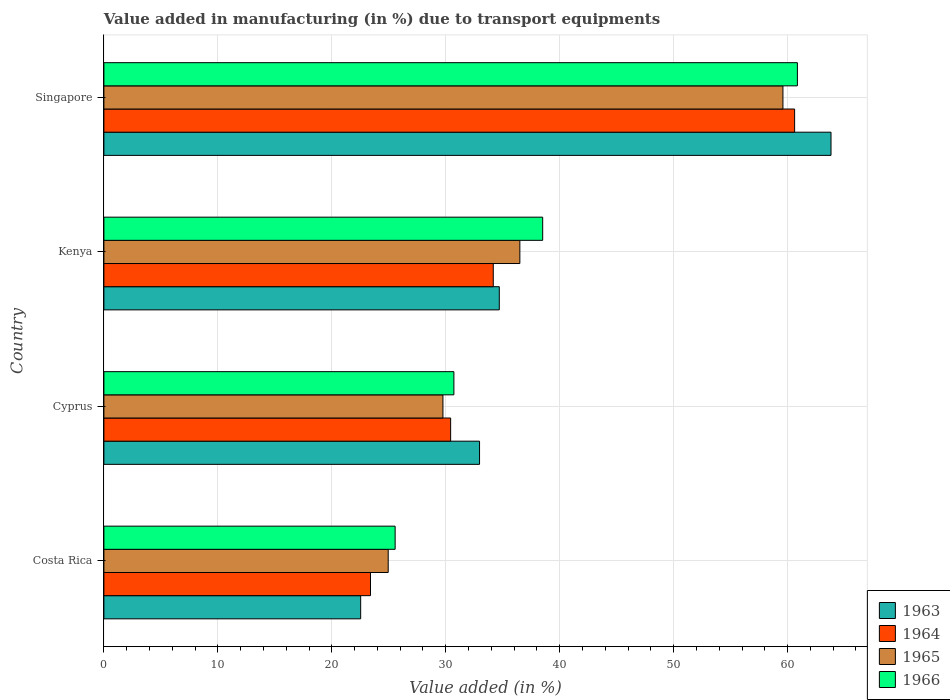How many groups of bars are there?
Make the answer very short. 4. Are the number of bars per tick equal to the number of legend labels?
Offer a very short reply. Yes. Are the number of bars on each tick of the Y-axis equal?
Offer a very short reply. Yes. How many bars are there on the 4th tick from the top?
Your answer should be compact. 4. How many bars are there on the 1st tick from the bottom?
Offer a terse response. 4. What is the label of the 2nd group of bars from the top?
Your answer should be very brief. Kenya. What is the percentage of value added in manufacturing due to transport equipments in 1966 in Singapore?
Make the answer very short. 60.86. Across all countries, what is the maximum percentage of value added in manufacturing due to transport equipments in 1966?
Offer a very short reply. 60.86. Across all countries, what is the minimum percentage of value added in manufacturing due to transport equipments in 1965?
Ensure brevity in your answer.  24.95. In which country was the percentage of value added in manufacturing due to transport equipments in 1963 maximum?
Keep it short and to the point. Singapore. What is the total percentage of value added in manufacturing due to transport equipments in 1966 in the graph?
Provide a succinct answer. 155.64. What is the difference between the percentage of value added in manufacturing due to transport equipments in 1964 in Costa Rica and that in Singapore?
Provide a short and direct response. -37.22. What is the difference between the percentage of value added in manufacturing due to transport equipments in 1964 in Costa Rica and the percentage of value added in manufacturing due to transport equipments in 1966 in Singapore?
Ensure brevity in your answer.  -37.46. What is the average percentage of value added in manufacturing due to transport equipments in 1963 per country?
Give a very brief answer. 38.5. What is the difference between the percentage of value added in manufacturing due to transport equipments in 1965 and percentage of value added in manufacturing due to transport equipments in 1964 in Costa Rica?
Make the answer very short. 1.55. What is the ratio of the percentage of value added in manufacturing due to transport equipments in 1964 in Kenya to that in Singapore?
Provide a short and direct response. 0.56. Is the difference between the percentage of value added in manufacturing due to transport equipments in 1965 in Cyprus and Kenya greater than the difference between the percentage of value added in manufacturing due to transport equipments in 1964 in Cyprus and Kenya?
Provide a short and direct response. No. What is the difference between the highest and the second highest percentage of value added in manufacturing due to transport equipments in 1963?
Your response must be concise. 29.11. What is the difference between the highest and the lowest percentage of value added in manufacturing due to transport equipments in 1966?
Your response must be concise. 35.3. What does the 1st bar from the top in Cyprus represents?
Keep it short and to the point. 1966. What does the 2nd bar from the bottom in Costa Rica represents?
Your answer should be very brief. 1964. Is it the case that in every country, the sum of the percentage of value added in manufacturing due to transport equipments in 1964 and percentage of value added in manufacturing due to transport equipments in 1965 is greater than the percentage of value added in manufacturing due to transport equipments in 1966?
Your response must be concise. Yes. How many bars are there?
Your answer should be very brief. 16. Are all the bars in the graph horizontal?
Offer a terse response. Yes. How many countries are there in the graph?
Your answer should be very brief. 4. Are the values on the major ticks of X-axis written in scientific E-notation?
Your answer should be compact. No. How many legend labels are there?
Offer a terse response. 4. How are the legend labels stacked?
Your response must be concise. Vertical. What is the title of the graph?
Give a very brief answer. Value added in manufacturing (in %) due to transport equipments. Does "1985" appear as one of the legend labels in the graph?
Ensure brevity in your answer.  No. What is the label or title of the X-axis?
Provide a succinct answer. Value added (in %). What is the label or title of the Y-axis?
Provide a succinct answer. Country. What is the Value added (in %) in 1963 in Costa Rica?
Your response must be concise. 22.53. What is the Value added (in %) of 1964 in Costa Rica?
Provide a short and direct response. 23.4. What is the Value added (in %) of 1965 in Costa Rica?
Make the answer very short. 24.95. What is the Value added (in %) in 1966 in Costa Rica?
Your response must be concise. 25.56. What is the Value added (in %) in 1963 in Cyprus?
Offer a very short reply. 32.97. What is the Value added (in %) of 1964 in Cyprus?
Make the answer very short. 30.43. What is the Value added (in %) in 1965 in Cyprus?
Your answer should be very brief. 29.75. What is the Value added (in %) in 1966 in Cyprus?
Your answer should be very brief. 30.72. What is the Value added (in %) in 1963 in Kenya?
Offer a terse response. 34.7. What is the Value added (in %) in 1964 in Kenya?
Your answer should be very brief. 34.17. What is the Value added (in %) in 1965 in Kenya?
Provide a short and direct response. 36.5. What is the Value added (in %) in 1966 in Kenya?
Ensure brevity in your answer.  38.51. What is the Value added (in %) of 1963 in Singapore?
Give a very brief answer. 63.81. What is the Value added (in %) in 1964 in Singapore?
Provide a succinct answer. 60.62. What is the Value added (in %) in 1965 in Singapore?
Your answer should be compact. 59.59. What is the Value added (in %) in 1966 in Singapore?
Provide a succinct answer. 60.86. Across all countries, what is the maximum Value added (in %) of 1963?
Make the answer very short. 63.81. Across all countries, what is the maximum Value added (in %) in 1964?
Offer a very short reply. 60.62. Across all countries, what is the maximum Value added (in %) of 1965?
Your answer should be very brief. 59.59. Across all countries, what is the maximum Value added (in %) of 1966?
Ensure brevity in your answer.  60.86. Across all countries, what is the minimum Value added (in %) of 1963?
Your answer should be very brief. 22.53. Across all countries, what is the minimum Value added (in %) in 1964?
Offer a terse response. 23.4. Across all countries, what is the minimum Value added (in %) in 1965?
Give a very brief answer. 24.95. Across all countries, what is the minimum Value added (in %) of 1966?
Offer a terse response. 25.56. What is the total Value added (in %) of 1963 in the graph?
Provide a short and direct response. 154.01. What is the total Value added (in %) in 1964 in the graph?
Offer a very short reply. 148.61. What is the total Value added (in %) in 1965 in the graph?
Offer a very short reply. 150.8. What is the total Value added (in %) of 1966 in the graph?
Give a very brief answer. 155.64. What is the difference between the Value added (in %) of 1963 in Costa Rica and that in Cyprus?
Your answer should be very brief. -10.43. What is the difference between the Value added (in %) of 1964 in Costa Rica and that in Cyprus?
Your answer should be very brief. -7.03. What is the difference between the Value added (in %) of 1965 in Costa Rica and that in Cyprus?
Ensure brevity in your answer.  -4.8. What is the difference between the Value added (in %) in 1966 in Costa Rica and that in Cyprus?
Your answer should be very brief. -5.16. What is the difference between the Value added (in %) of 1963 in Costa Rica and that in Kenya?
Your response must be concise. -12.17. What is the difference between the Value added (in %) of 1964 in Costa Rica and that in Kenya?
Offer a very short reply. -10.77. What is the difference between the Value added (in %) of 1965 in Costa Rica and that in Kenya?
Make the answer very short. -11.55. What is the difference between the Value added (in %) in 1966 in Costa Rica and that in Kenya?
Offer a terse response. -12.95. What is the difference between the Value added (in %) of 1963 in Costa Rica and that in Singapore?
Ensure brevity in your answer.  -41.28. What is the difference between the Value added (in %) of 1964 in Costa Rica and that in Singapore?
Give a very brief answer. -37.22. What is the difference between the Value added (in %) in 1965 in Costa Rica and that in Singapore?
Provide a succinct answer. -34.64. What is the difference between the Value added (in %) of 1966 in Costa Rica and that in Singapore?
Offer a terse response. -35.3. What is the difference between the Value added (in %) of 1963 in Cyprus and that in Kenya?
Give a very brief answer. -1.73. What is the difference between the Value added (in %) of 1964 in Cyprus and that in Kenya?
Offer a very short reply. -3.74. What is the difference between the Value added (in %) of 1965 in Cyprus and that in Kenya?
Provide a short and direct response. -6.75. What is the difference between the Value added (in %) in 1966 in Cyprus and that in Kenya?
Your answer should be very brief. -7.79. What is the difference between the Value added (in %) in 1963 in Cyprus and that in Singapore?
Offer a very short reply. -30.84. What is the difference between the Value added (in %) of 1964 in Cyprus and that in Singapore?
Your answer should be compact. -30.19. What is the difference between the Value added (in %) of 1965 in Cyprus and that in Singapore?
Your answer should be compact. -29.84. What is the difference between the Value added (in %) of 1966 in Cyprus and that in Singapore?
Offer a very short reply. -30.14. What is the difference between the Value added (in %) of 1963 in Kenya and that in Singapore?
Your response must be concise. -29.11. What is the difference between the Value added (in %) in 1964 in Kenya and that in Singapore?
Your answer should be very brief. -26.45. What is the difference between the Value added (in %) of 1965 in Kenya and that in Singapore?
Offer a very short reply. -23.09. What is the difference between the Value added (in %) of 1966 in Kenya and that in Singapore?
Provide a succinct answer. -22.35. What is the difference between the Value added (in %) in 1963 in Costa Rica and the Value added (in %) in 1964 in Cyprus?
Your answer should be very brief. -7.9. What is the difference between the Value added (in %) in 1963 in Costa Rica and the Value added (in %) in 1965 in Cyprus?
Offer a very short reply. -7.22. What is the difference between the Value added (in %) in 1963 in Costa Rica and the Value added (in %) in 1966 in Cyprus?
Your response must be concise. -8.18. What is the difference between the Value added (in %) of 1964 in Costa Rica and the Value added (in %) of 1965 in Cyprus?
Offer a very short reply. -6.36. What is the difference between the Value added (in %) in 1964 in Costa Rica and the Value added (in %) in 1966 in Cyprus?
Your answer should be very brief. -7.32. What is the difference between the Value added (in %) in 1965 in Costa Rica and the Value added (in %) in 1966 in Cyprus?
Keep it short and to the point. -5.77. What is the difference between the Value added (in %) in 1963 in Costa Rica and the Value added (in %) in 1964 in Kenya?
Offer a very short reply. -11.64. What is the difference between the Value added (in %) of 1963 in Costa Rica and the Value added (in %) of 1965 in Kenya?
Keep it short and to the point. -13.97. What is the difference between the Value added (in %) of 1963 in Costa Rica and the Value added (in %) of 1966 in Kenya?
Your response must be concise. -15.97. What is the difference between the Value added (in %) of 1964 in Costa Rica and the Value added (in %) of 1965 in Kenya?
Offer a very short reply. -13.11. What is the difference between the Value added (in %) in 1964 in Costa Rica and the Value added (in %) in 1966 in Kenya?
Make the answer very short. -15.11. What is the difference between the Value added (in %) of 1965 in Costa Rica and the Value added (in %) of 1966 in Kenya?
Give a very brief answer. -13.56. What is the difference between the Value added (in %) of 1963 in Costa Rica and the Value added (in %) of 1964 in Singapore?
Your answer should be compact. -38.08. What is the difference between the Value added (in %) of 1963 in Costa Rica and the Value added (in %) of 1965 in Singapore?
Give a very brief answer. -37.06. What is the difference between the Value added (in %) in 1963 in Costa Rica and the Value added (in %) in 1966 in Singapore?
Give a very brief answer. -38.33. What is the difference between the Value added (in %) in 1964 in Costa Rica and the Value added (in %) in 1965 in Singapore?
Provide a succinct answer. -36.19. What is the difference between the Value added (in %) in 1964 in Costa Rica and the Value added (in %) in 1966 in Singapore?
Your answer should be compact. -37.46. What is the difference between the Value added (in %) of 1965 in Costa Rica and the Value added (in %) of 1966 in Singapore?
Provide a short and direct response. -35.91. What is the difference between the Value added (in %) of 1963 in Cyprus and the Value added (in %) of 1964 in Kenya?
Make the answer very short. -1.2. What is the difference between the Value added (in %) of 1963 in Cyprus and the Value added (in %) of 1965 in Kenya?
Provide a short and direct response. -3.54. What is the difference between the Value added (in %) of 1963 in Cyprus and the Value added (in %) of 1966 in Kenya?
Provide a short and direct response. -5.54. What is the difference between the Value added (in %) in 1964 in Cyprus and the Value added (in %) in 1965 in Kenya?
Your answer should be very brief. -6.07. What is the difference between the Value added (in %) in 1964 in Cyprus and the Value added (in %) in 1966 in Kenya?
Your answer should be compact. -8.08. What is the difference between the Value added (in %) of 1965 in Cyprus and the Value added (in %) of 1966 in Kenya?
Your response must be concise. -8.75. What is the difference between the Value added (in %) of 1963 in Cyprus and the Value added (in %) of 1964 in Singapore?
Offer a very short reply. -27.65. What is the difference between the Value added (in %) in 1963 in Cyprus and the Value added (in %) in 1965 in Singapore?
Your answer should be compact. -26.62. What is the difference between the Value added (in %) in 1963 in Cyprus and the Value added (in %) in 1966 in Singapore?
Provide a succinct answer. -27.89. What is the difference between the Value added (in %) in 1964 in Cyprus and the Value added (in %) in 1965 in Singapore?
Offer a terse response. -29.16. What is the difference between the Value added (in %) in 1964 in Cyprus and the Value added (in %) in 1966 in Singapore?
Keep it short and to the point. -30.43. What is the difference between the Value added (in %) of 1965 in Cyprus and the Value added (in %) of 1966 in Singapore?
Your answer should be very brief. -31.11. What is the difference between the Value added (in %) in 1963 in Kenya and the Value added (in %) in 1964 in Singapore?
Provide a short and direct response. -25.92. What is the difference between the Value added (in %) of 1963 in Kenya and the Value added (in %) of 1965 in Singapore?
Offer a terse response. -24.89. What is the difference between the Value added (in %) of 1963 in Kenya and the Value added (in %) of 1966 in Singapore?
Provide a short and direct response. -26.16. What is the difference between the Value added (in %) in 1964 in Kenya and the Value added (in %) in 1965 in Singapore?
Ensure brevity in your answer.  -25.42. What is the difference between the Value added (in %) of 1964 in Kenya and the Value added (in %) of 1966 in Singapore?
Ensure brevity in your answer.  -26.69. What is the difference between the Value added (in %) of 1965 in Kenya and the Value added (in %) of 1966 in Singapore?
Provide a short and direct response. -24.36. What is the average Value added (in %) of 1963 per country?
Provide a succinct answer. 38.5. What is the average Value added (in %) of 1964 per country?
Your answer should be compact. 37.15. What is the average Value added (in %) of 1965 per country?
Provide a short and direct response. 37.7. What is the average Value added (in %) of 1966 per country?
Your answer should be very brief. 38.91. What is the difference between the Value added (in %) in 1963 and Value added (in %) in 1964 in Costa Rica?
Ensure brevity in your answer.  -0.86. What is the difference between the Value added (in %) in 1963 and Value added (in %) in 1965 in Costa Rica?
Provide a succinct answer. -2.42. What is the difference between the Value added (in %) of 1963 and Value added (in %) of 1966 in Costa Rica?
Ensure brevity in your answer.  -3.03. What is the difference between the Value added (in %) in 1964 and Value added (in %) in 1965 in Costa Rica?
Offer a very short reply. -1.55. What is the difference between the Value added (in %) of 1964 and Value added (in %) of 1966 in Costa Rica?
Ensure brevity in your answer.  -2.16. What is the difference between the Value added (in %) in 1965 and Value added (in %) in 1966 in Costa Rica?
Your answer should be compact. -0.61. What is the difference between the Value added (in %) in 1963 and Value added (in %) in 1964 in Cyprus?
Provide a short and direct response. 2.54. What is the difference between the Value added (in %) of 1963 and Value added (in %) of 1965 in Cyprus?
Provide a short and direct response. 3.21. What is the difference between the Value added (in %) of 1963 and Value added (in %) of 1966 in Cyprus?
Give a very brief answer. 2.25. What is the difference between the Value added (in %) of 1964 and Value added (in %) of 1965 in Cyprus?
Your answer should be compact. 0.68. What is the difference between the Value added (in %) of 1964 and Value added (in %) of 1966 in Cyprus?
Offer a terse response. -0.29. What is the difference between the Value added (in %) in 1965 and Value added (in %) in 1966 in Cyprus?
Make the answer very short. -0.96. What is the difference between the Value added (in %) in 1963 and Value added (in %) in 1964 in Kenya?
Provide a succinct answer. 0.53. What is the difference between the Value added (in %) in 1963 and Value added (in %) in 1965 in Kenya?
Provide a short and direct response. -1.8. What is the difference between the Value added (in %) in 1963 and Value added (in %) in 1966 in Kenya?
Offer a very short reply. -3.81. What is the difference between the Value added (in %) in 1964 and Value added (in %) in 1965 in Kenya?
Make the answer very short. -2.33. What is the difference between the Value added (in %) in 1964 and Value added (in %) in 1966 in Kenya?
Your answer should be very brief. -4.34. What is the difference between the Value added (in %) in 1965 and Value added (in %) in 1966 in Kenya?
Ensure brevity in your answer.  -2. What is the difference between the Value added (in %) in 1963 and Value added (in %) in 1964 in Singapore?
Provide a short and direct response. 3.19. What is the difference between the Value added (in %) of 1963 and Value added (in %) of 1965 in Singapore?
Ensure brevity in your answer.  4.22. What is the difference between the Value added (in %) in 1963 and Value added (in %) in 1966 in Singapore?
Provide a short and direct response. 2.95. What is the difference between the Value added (in %) of 1964 and Value added (in %) of 1965 in Singapore?
Provide a succinct answer. 1.03. What is the difference between the Value added (in %) of 1964 and Value added (in %) of 1966 in Singapore?
Your answer should be very brief. -0.24. What is the difference between the Value added (in %) in 1965 and Value added (in %) in 1966 in Singapore?
Give a very brief answer. -1.27. What is the ratio of the Value added (in %) in 1963 in Costa Rica to that in Cyprus?
Make the answer very short. 0.68. What is the ratio of the Value added (in %) in 1964 in Costa Rica to that in Cyprus?
Offer a very short reply. 0.77. What is the ratio of the Value added (in %) of 1965 in Costa Rica to that in Cyprus?
Your response must be concise. 0.84. What is the ratio of the Value added (in %) of 1966 in Costa Rica to that in Cyprus?
Keep it short and to the point. 0.83. What is the ratio of the Value added (in %) in 1963 in Costa Rica to that in Kenya?
Provide a short and direct response. 0.65. What is the ratio of the Value added (in %) in 1964 in Costa Rica to that in Kenya?
Your answer should be compact. 0.68. What is the ratio of the Value added (in %) in 1965 in Costa Rica to that in Kenya?
Provide a short and direct response. 0.68. What is the ratio of the Value added (in %) in 1966 in Costa Rica to that in Kenya?
Offer a very short reply. 0.66. What is the ratio of the Value added (in %) in 1963 in Costa Rica to that in Singapore?
Provide a succinct answer. 0.35. What is the ratio of the Value added (in %) in 1964 in Costa Rica to that in Singapore?
Offer a very short reply. 0.39. What is the ratio of the Value added (in %) in 1965 in Costa Rica to that in Singapore?
Ensure brevity in your answer.  0.42. What is the ratio of the Value added (in %) in 1966 in Costa Rica to that in Singapore?
Ensure brevity in your answer.  0.42. What is the ratio of the Value added (in %) of 1963 in Cyprus to that in Kenya?
Offer a terse response. 0.95. What is the ratio of the Value added (in %) in 1964 in Cyprus to that in Kenya?
Offer a terse response. 0.89. What is the ratio of the Value added (in %) of 1965 in Cyprus to that in Kenya?
Your response must be concise. 0.82. What is the ratio of the Value added (in %) of 1966 in Cyprus to that in Kenya?
Keep it short and to the point. 0.8. What is the ratio of the Value added (in %) of 1963 in Cyprus to that in Singapore?
Offer a terse response. 0.52. What is the ratio of the Value added (in %) of 1964 in Cyprus to that in Singapore?
Provide a succinct answer. 0.5. What is the ratio of the Value added (in %) of 1965 in Cyprus to that in Singapore?
Your answer should be very brief. 0.5. What is the ratio of the Value added (in %) of 1966 in Cyprus to that in Singapore?
Provide a short and direct response. 0.5. What is the ratio of the Value added (in %) in 1963 in Kenya to that in Singapore?
Your response must be concise. 0.54. What is the ratio of the Value added (in %) in 1964 in Kenya to that in Singapore?
Provide a short and direct response. 0.56. What is the ratio of the Value added (in %) of 1965 in Kenya to that in Singapore?
Offer a very short reply. 0.61. What is the ratio of the Value added (in %) of 1966 in Kenya to that in Singapore?
Ensure brevity in your answer.  0.63. What is the difference between the highest and the second highest Value added (in %) in 1963?
Make the answer very short. 29.11. What is the difference between the highest and the second highest Value added (in %) in 1964?
Offer a very short reply. 26.45. What is the difference between the highest and the second highest Value added (in %) of 1965?
Give a very brief answer. 23.09. What is the difference between the highest and the second highest Value added (in %) in 1966?
Provide a short and direct response. 22.35. What is the difference between the highest and the lowest Value added (in %) in 1963?
Your answer should be compact. 41.28. What is the difference between the highest and the lowest Value added (in %) of 1964?
Your answer should be compact. 37.22. What is the difference between the highest and the lowest Value added (in %) in 1965?
Offer a very short reply. 34.64. What is the difference between the highest and the lowest Value added (in %) in 1966?
Keep it short and to the point. 35.3. 